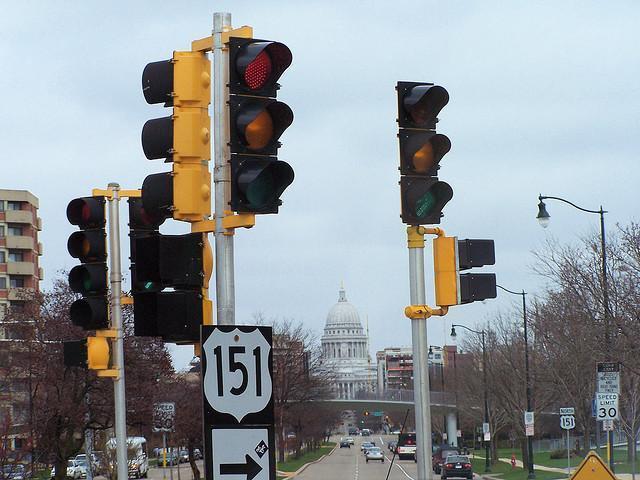How many traffic lights are in the picture?
Give a very brief answer. 6. How many people are wearing glasses?
Give a very brief answer. 0. 